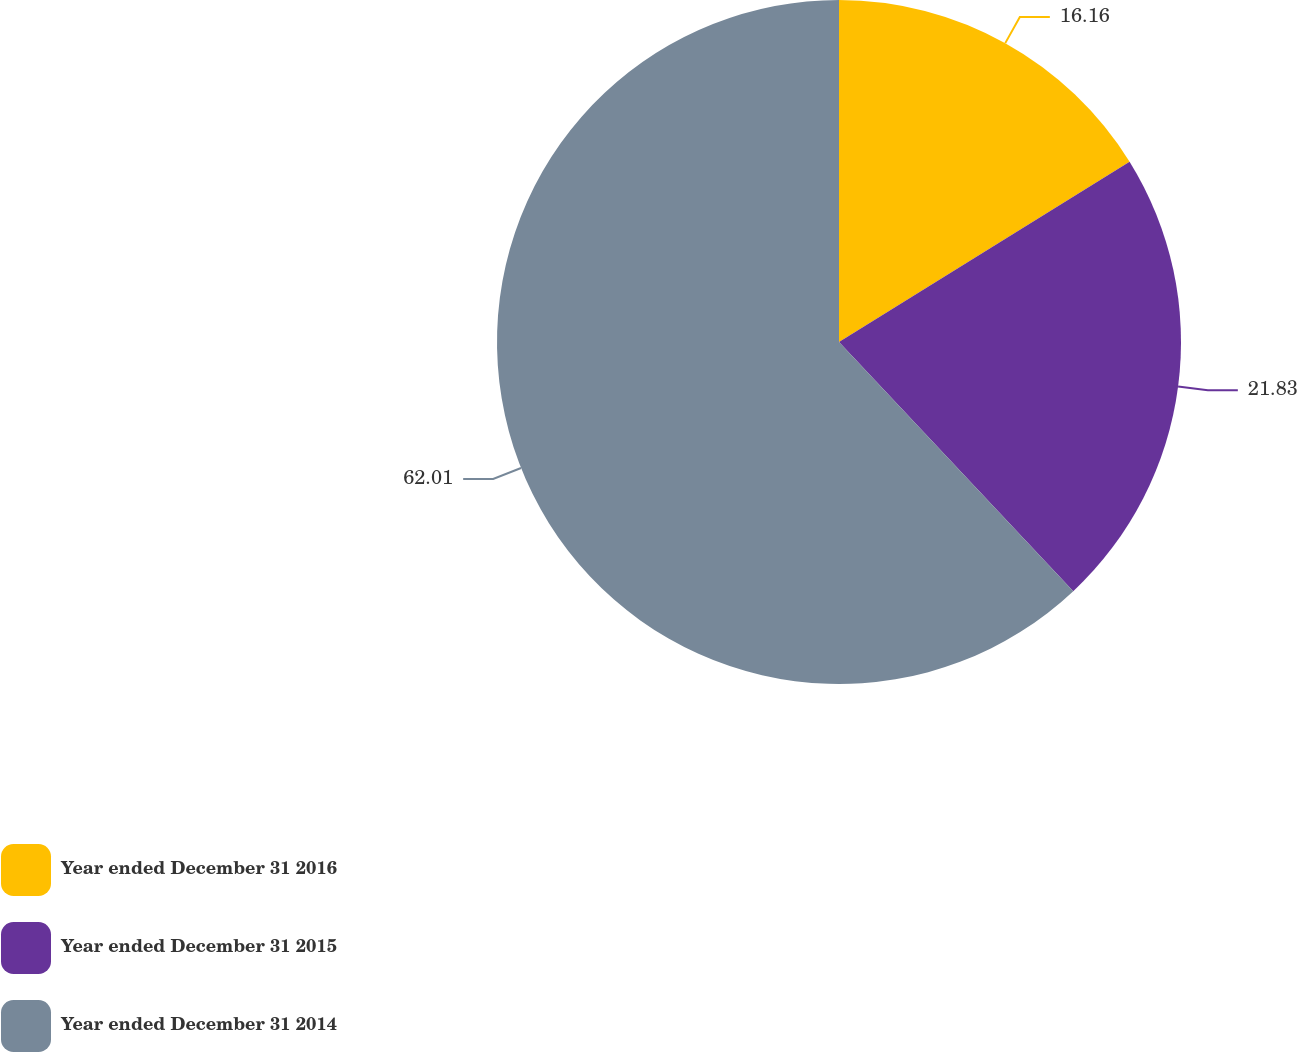<chart> <loc_0><loc_0><loc_500><loc_500><pie_chart><fcel>Year ended December 31 2016<fcel>Year ended December 31 2015<fcel>Year ended December 31 2014<nl><fcel>16.16%<fcel>21.83%<fcel>62.01%<nl></chart> 